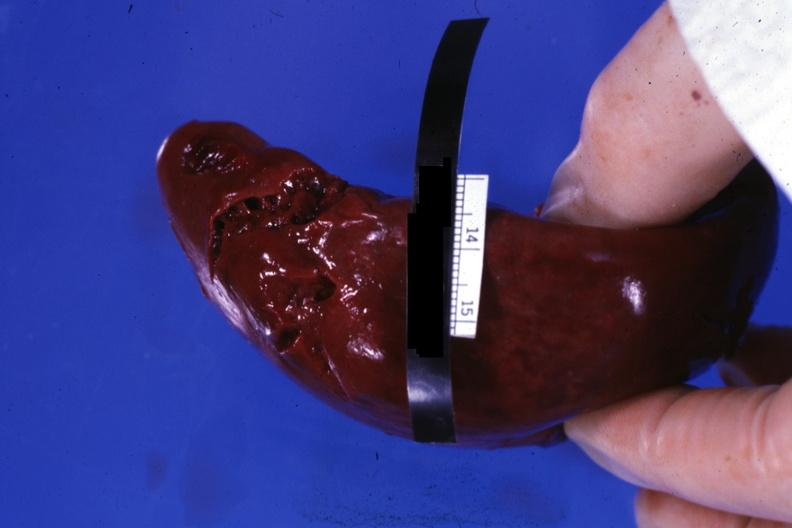s carcinoma metastatic lung present?
Answer the question using a single word or phrase. No 